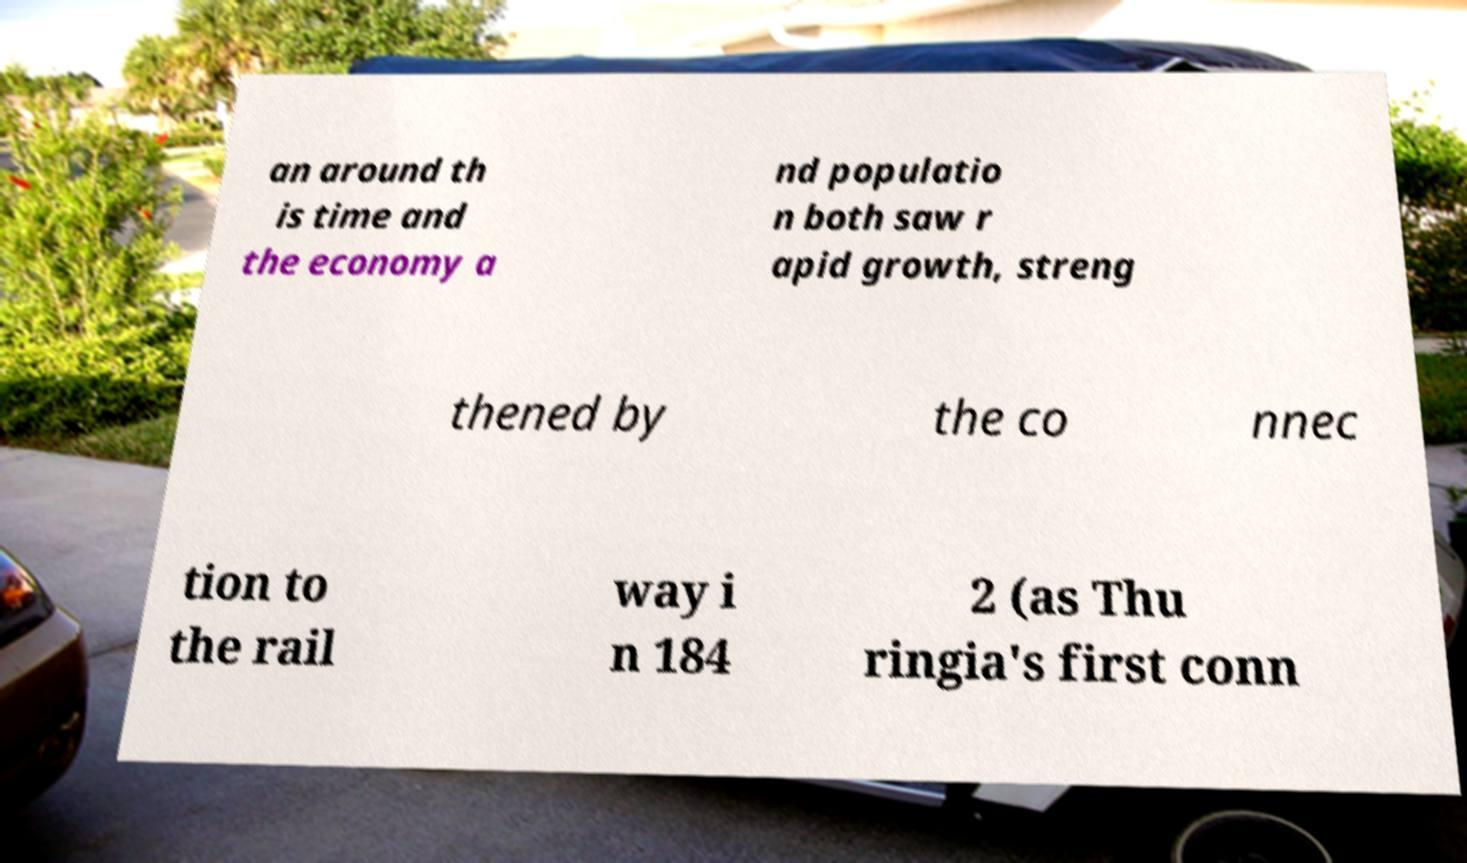Please read and relay the text visible in this image. What does it say? an around th is time and the economy a nd populatio n both saw r apid growth, streng thened by the co nnec tion to the rail way i n 184 2 (as Thu ringia's first conn 